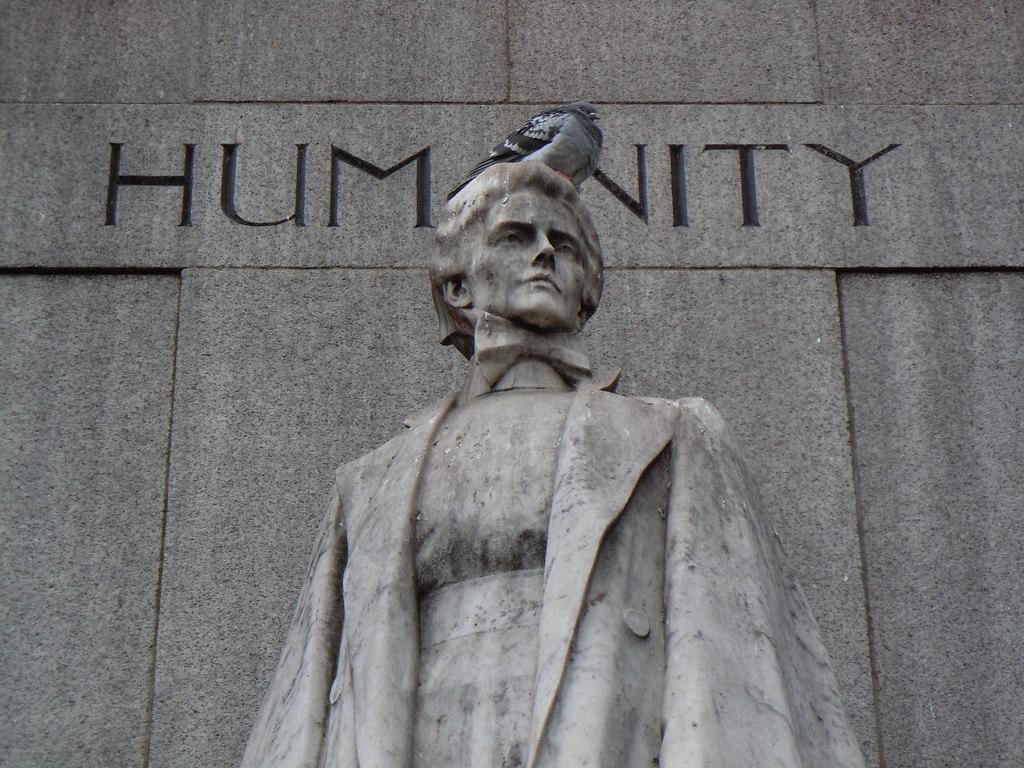What is the main subject in the image? There is a statue in the image. What else can be seen in the image besides the statue? There is a wall in the image. How many lizards are crawling on the statue in the image? There are no lizards present in the image; it only features a statue and a wall. 